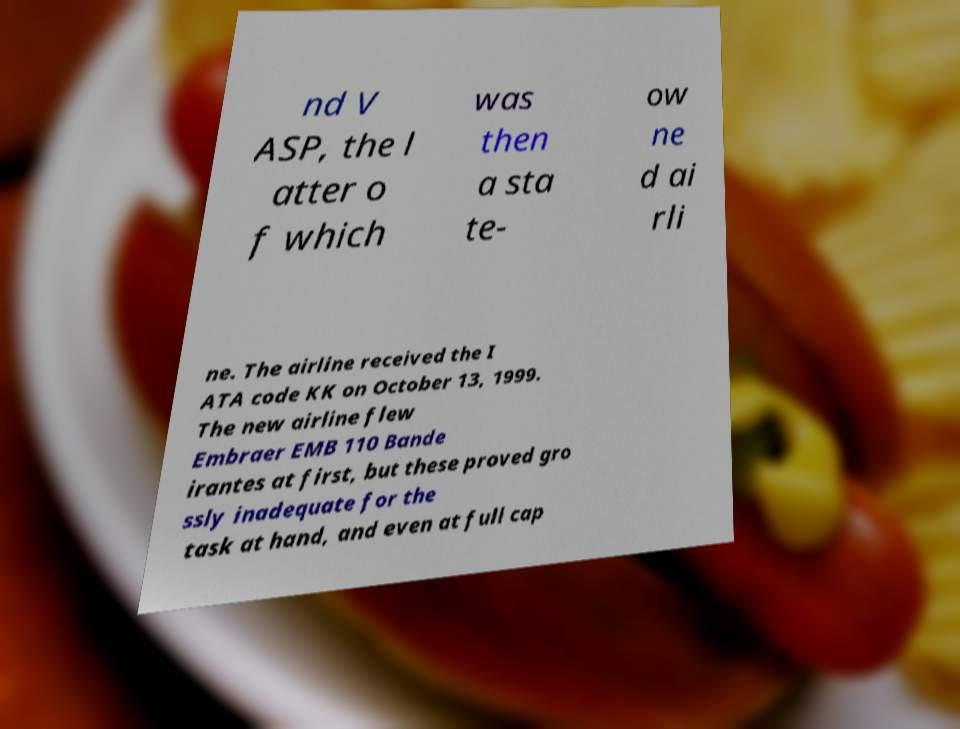Can you accurately transcribe the text from the provided image for me? nd V ASP, the l atter o f which was then a sta te- ow ne d ai rli ne. The airline received the I ATA code KK on October 13, 1999. The new airline flew Embraer EMB 110 Bande irantes at first, but these proved gro ssly inadequate for the task at hand, and even at full cap 